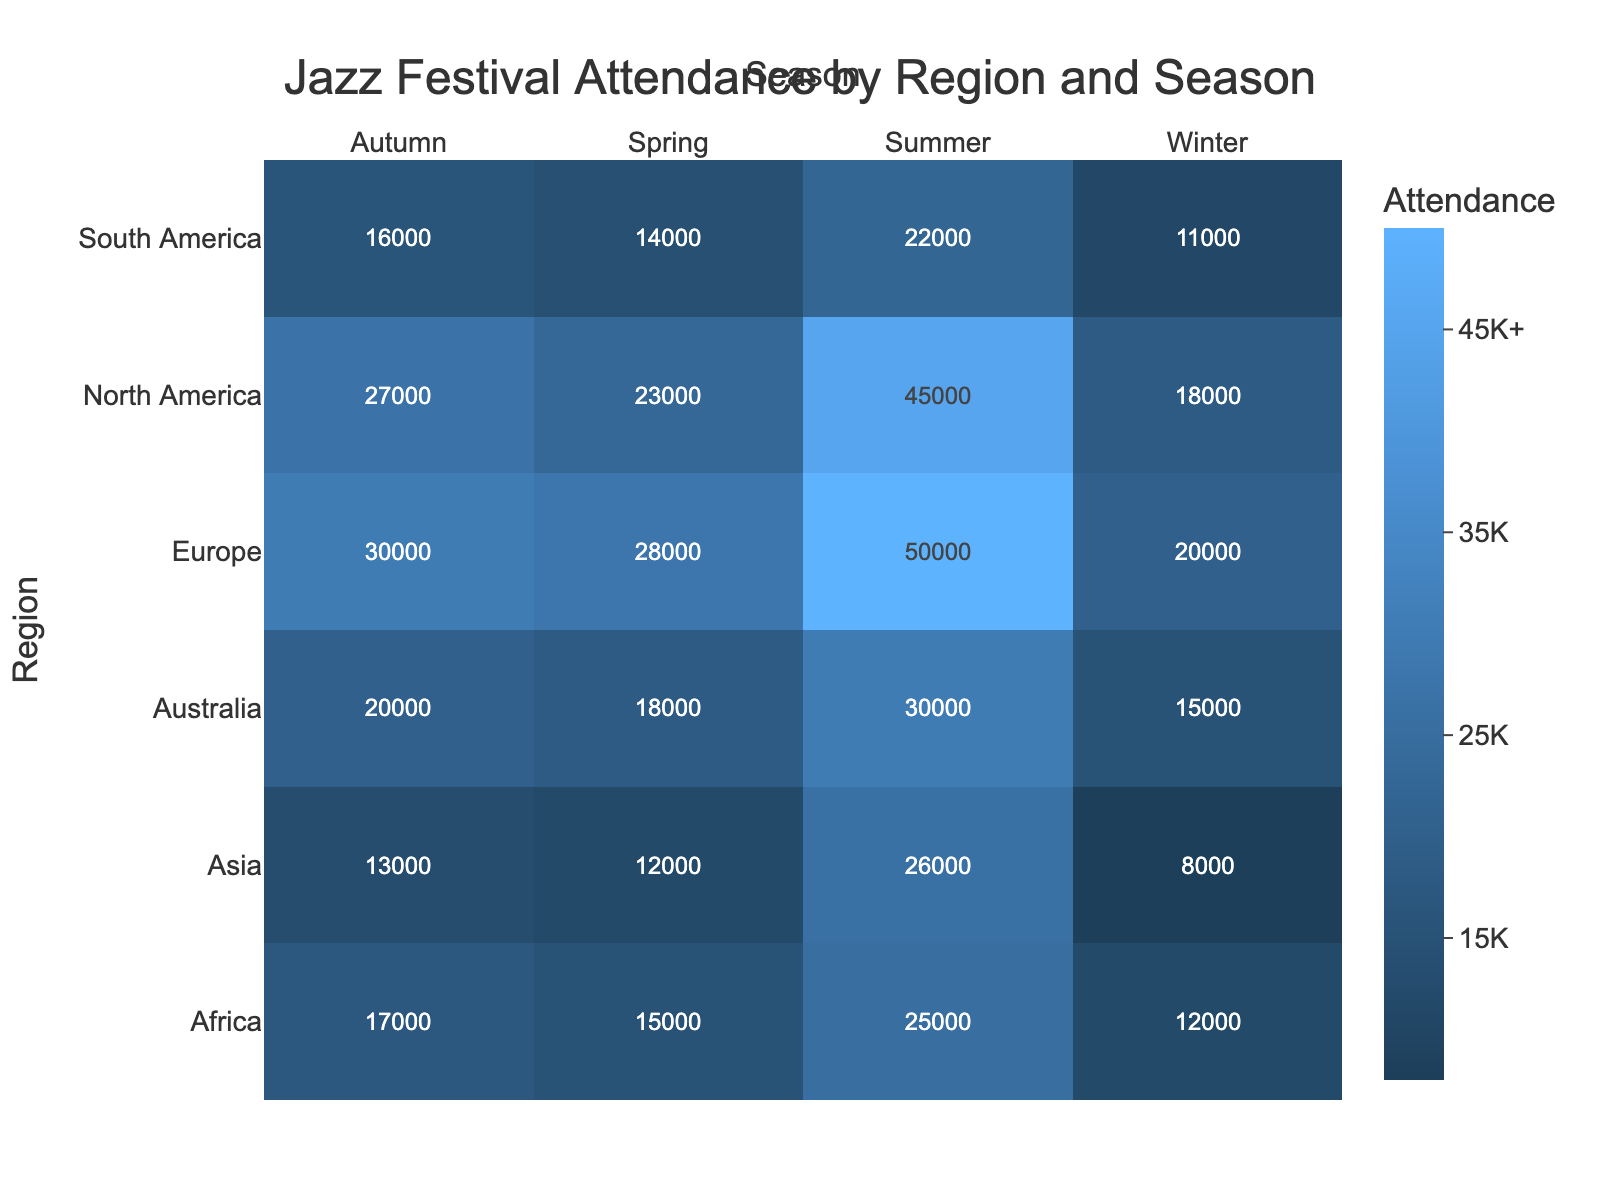What is the title of the heatmap? The title is positioned at the top center of the heatmap and it contains the main idea summarized in a few words.
Answer: Jazz Festival Attendance by Region and Season Which region has the highest attendance in the summer season? Look at the column labeled 'Summer' and identify the row with the highest value.
Answer: Europe How much higher is North America's attendance in Summer compared to Spring? Find North America's attendance in both Summer and Spring, then subtract the Spring value from the Summer value (45000 - 23000).
Answer: 22000 Which season generally has the lowest attendance across all regions? Check each seasonal column and identify the season with the lowest overall numbers.
Answer: Winter Identify the region and season with the lowest attendance. Find the cell with the lowest value in the heatmap, noting its corresponding row and column.
Answer: Asia, Winter Is attendance in Europe higher in Spring or Autumn? Compare the attendance values in Europe for Spring and Autumn.
Answer: Autumn Which two regions have the closest attendance numbers in Autumn? Find the Autumn column and determine which two regions have the most similar values.
Answer: South America and Africa What is the average attendance for jazz festivals in Australia across all seasons? Sum Australia's attendance values for all seasons and divide by the number of seasons (18000 + 30000 + 20000 + 15000) / 4.
Answer: 20750 How does Asia's attendance in Summer compare with North America's in Winter? Identify both values and compare them (Asia: 26000, North America: 18000).
Answer: Higher What is the total attendance for jazz festivals in North America throughout the year? Sum North America's attendance values across all four seasons (23000 + 45000 + 27000 + 18000).
Answer: 113000 